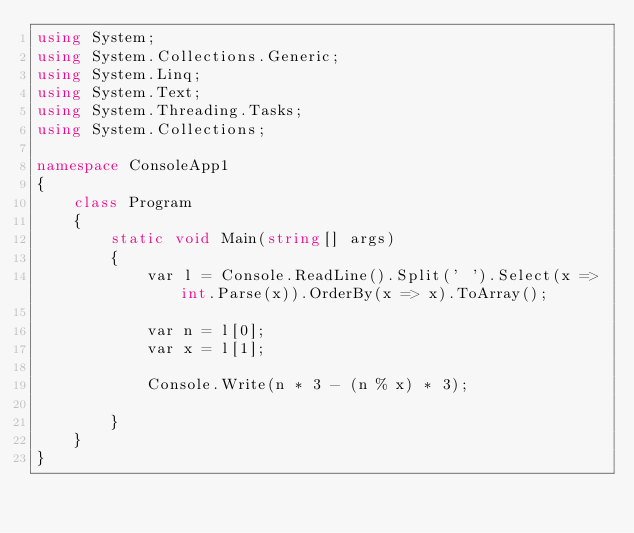Convert code to text. <code><loc_0><loc_0><loc_500><loc_500><_C#_>using System;
using System.Collections.Generic;
using System.Linq;
using System.Text;
using System.Threading.Tasks;
using System.Collections;

namespace ConsoleApp1
{
    class Program
    {
        static void Main(string[] args)
        {
            var l = Console.ReadLine().Split(' ').Select(x => int.Parse(x)).OrderBy(x => x).ToArray();

            var n = l[0];
            var x = l[1];

            Console.Write(n * 3 - (n % x) * 3);
            
        }
    }
}
</code> 